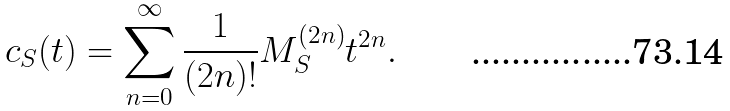<formula> <loc_0><loc_0><loc_500><loc_500>c _ { S } ( t ) = \sum _ { n = 0 } ^ { \infty } \frac { 1 } { ( 2 n ) ! } M _ { S } ^ { ( 2 n ) } t ^ { 2 n } .</formula> 